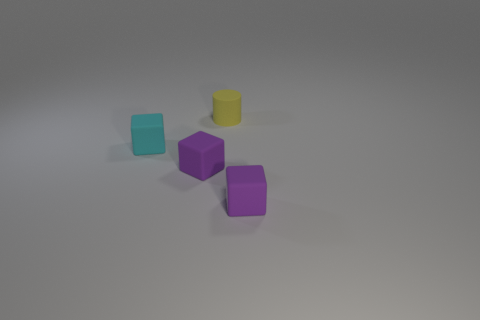Add 1 purple cubes. How many objects exist? 5 Subtract all cubes. How many objects are left? 1 Subtract all cyan blocks. Subtract all yellow things. How many objects are left? 2 Add 2 cyan objects. How many cyan objects are left? 3 Add 3 purple matte objects. How many purple matte objects exist? 5 Subtract 0 brown cylinders. How many objects are left? 4 